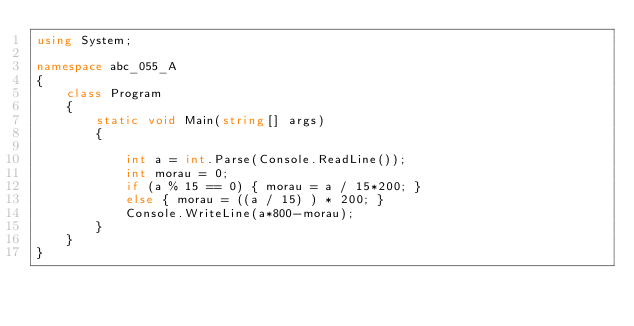Convert code to text. <code><loc_0><loc_0><loc_500><loc_500><_C#_>using System;

namespace abc_055_A
{
    class Program
    {
        static void Main(string[] args)
        {

            int a = int.Parse(Console.ReadLine());
            int morau = 0;
            if (a % 15 == 0) { morau = a / 15*200; }
            else { morau = ((a / 15) ) * 200; }
            Console.WriteLine(a*800-morau);
        }
    }
}
</code> 